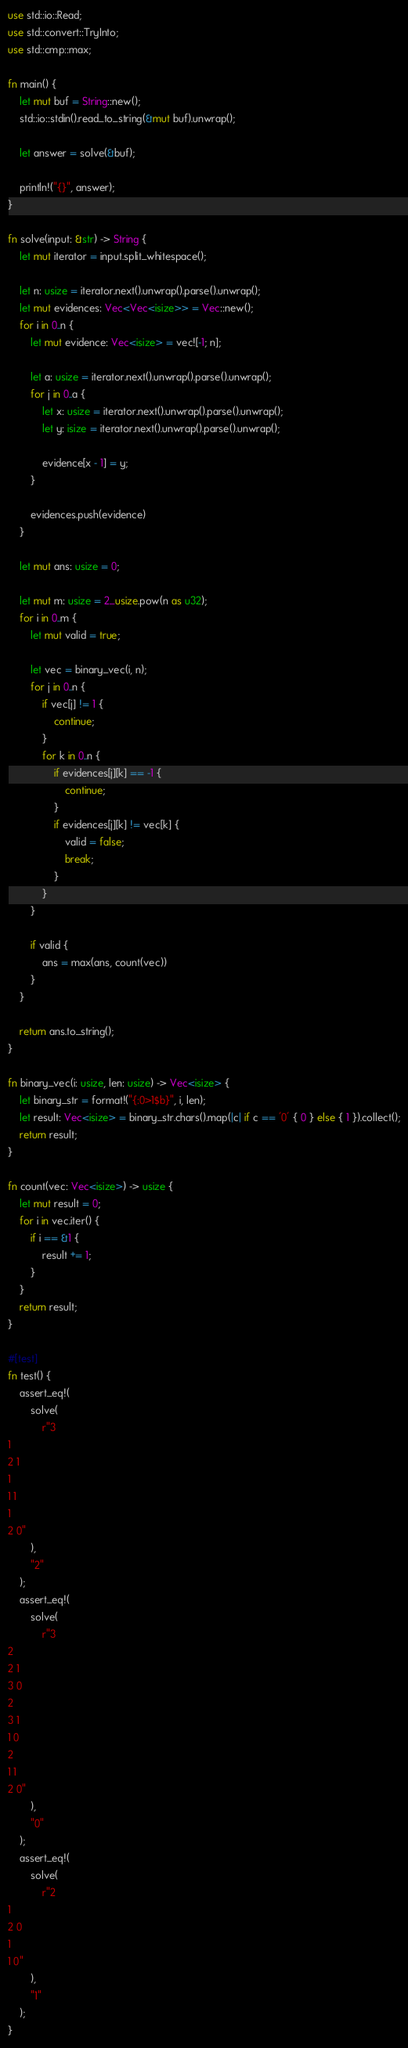Convert code to text. <code><loc_0><loc_0><loc_500><loc_500><_Rust_>use std::io::Read;
use std::convert::TryInto;
use std::cmp::max;

fn main() {
    let mut buf = String::new();
    std::io::stdin().read_to_string(&mut buf).unwrap();

    let answer = solve(&buf);

    println!("{}", answer);
}

fn solve(input: &str) -> String {
    let mut iterator = input.split_whitespace();

    let n: usize = iterator.next().unwrap().parse().unwrap();
    let mut evidences: Vec<Vec<isize>> = Vec::new();
    for i in 0..n {
        let mut evidence: Vec<isize> = vec![-1; n];

        let a: usize = iterator.next().unwrap().parse().unwrap();
        for j in 0..a {
            let x: usize = iterator.next().unwrap().parse().unwrap();
            let y: isize = iterator.next().unwrap().parse().unwrap();

            evidence[x - 1] = y;
        }

        evidences.push(evidence)
    }

    let mut ans: usize = 0;

    let mut m: usize = 2_usize.pow(n as u32);
    for i in 0..m {
        let mut valid = true;

        let vec = binary_vec(i, n);
        for j in 0..n {
            if vec[j] != 1 {
                continue;
            }
            for k in 0..n {
                if evidences[j][k] == -1 {
                    continue;
                }
                if evidences[j][k] != vec[k] {
                    valid = false;
                    break;
                }
            }
        }

        if valid {
            ans = max(ans, count(vec))
        }
    }

    return ans.to_string();
}

fn binary_vec(i: usize, len: usize) -> Vec<isize> {
    let binary_str = format!("{:0>1$b}", i, len);
    let result: Vec<isize> = binary_str.chars().map(|c| if c == '0' { 0 } else { 1 }).collect();
    return result;
}

fn count(vec: Vec<isize>) -> usize {
    let mut result = 0;
    for i in vec.iter() {
        if i == &1 {
            result += 1;
        }
    }
    return result;
}

#[test]
fn test() {
    assert_eq!(
        solve(
            r"3
1
2 1
1
1 1
1
2 0"
        ),
        "2"
    );
    assert_eq!(
        solve(
            r"3
2
2 1
3 0
2
3 1
1 0
2
1 1
2 0"
        ),
        "0"
    );
    assert_eq!(
        solve(
            r"2
1
2 0
1
1 0"
        ),
        "1"
    );
}
</code> 